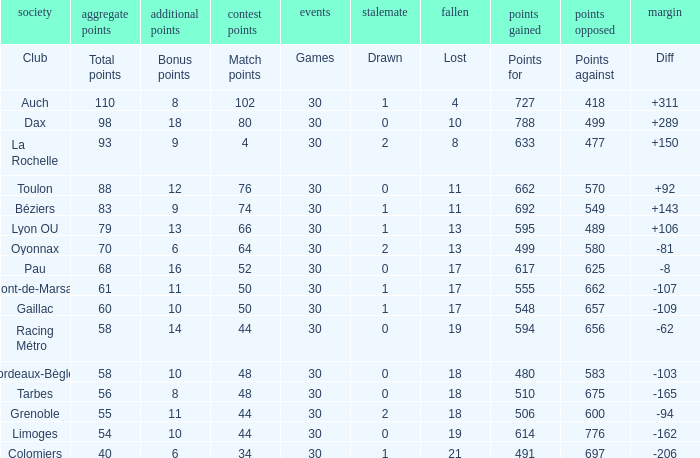What is the amount of match points for a club that lost 18 and has 11 bonus points? 44.0. 